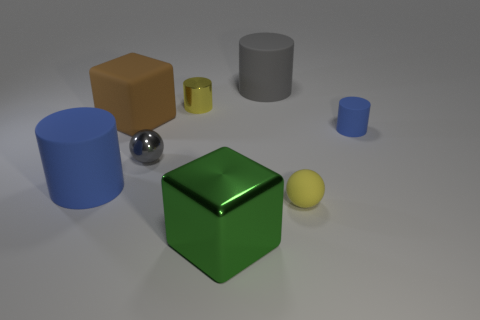Add 2 large gray cubes. How many objects exist? 10 Subtract all gray spheres. Subtract all red cylinders. How many spheres are left? 1 Subtract all balls. How many objects are left? 6 Add 1 small blue matte things. How many small blue matte things exist? 2 Subtract 0 brown spheres. How many objects are left? 8 Subtract all tiny purple metallic objects. Subtract all big rubber cubes. How many objects are left? 7 Add 2 matte blocks. How many matte blocks are left? 3 